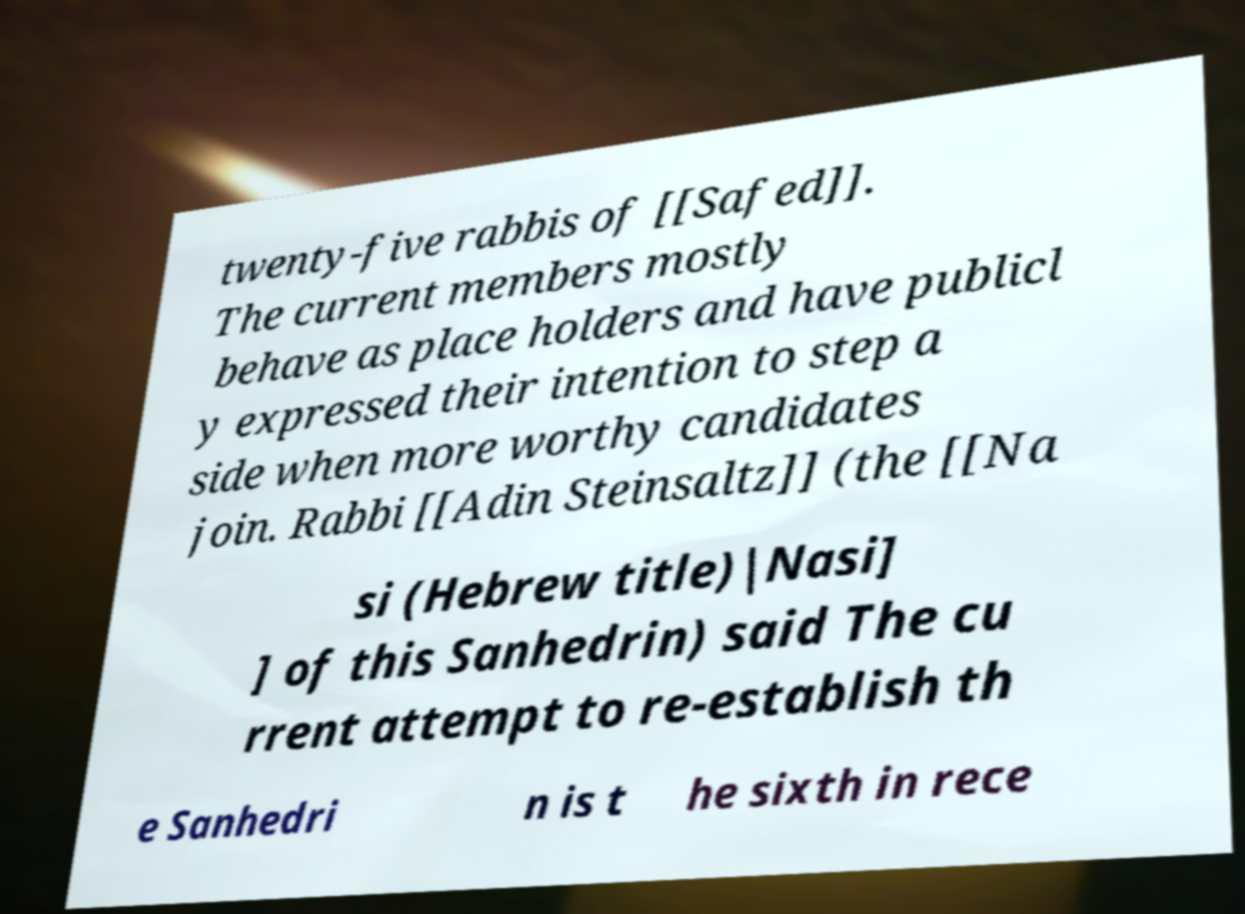Please read and relay the text visible in this image. What does it say? twenty-five rabbis of [[Safed]]. The current members mostly behave as place holders and have publicl y expressed their intention to step a side when more worthy candidates join. Rabbi [[Adin Steinsaltz]] (the [[Na si (Hebrew title)|Nasi] ] of this Sanhedrin) said The cu rrent attempt to re-establish th e Sanhedri n is t he sixth in rece 